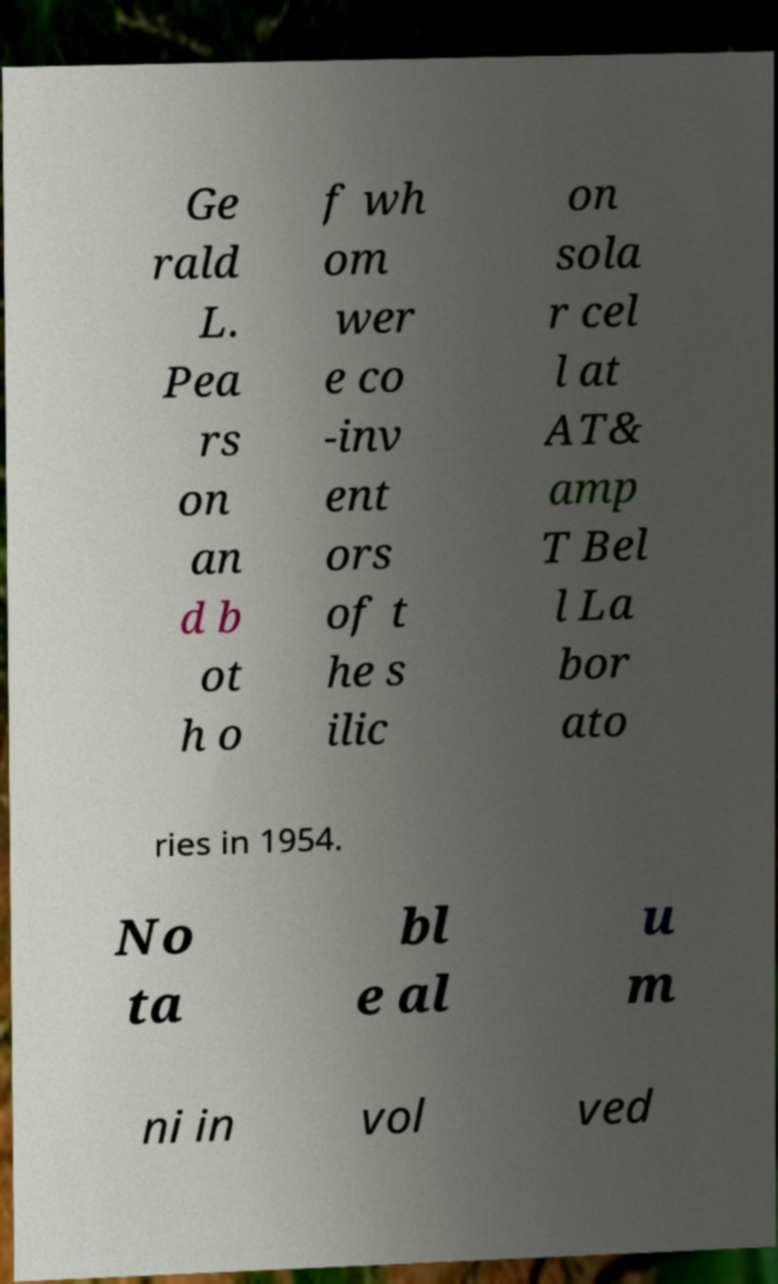Can you read and provide the text displayed in the image?This photo seems to have some interesting text. Can you extract and type it out for me? Ge rald L. Pea rs on an d b ot h o f wh om wer e co -inv ent ors of t he s ilic on sola r cel l at AT& amp T Bel l La bor ato ries in 1954. No ta bl e al u m ni in vol ved 